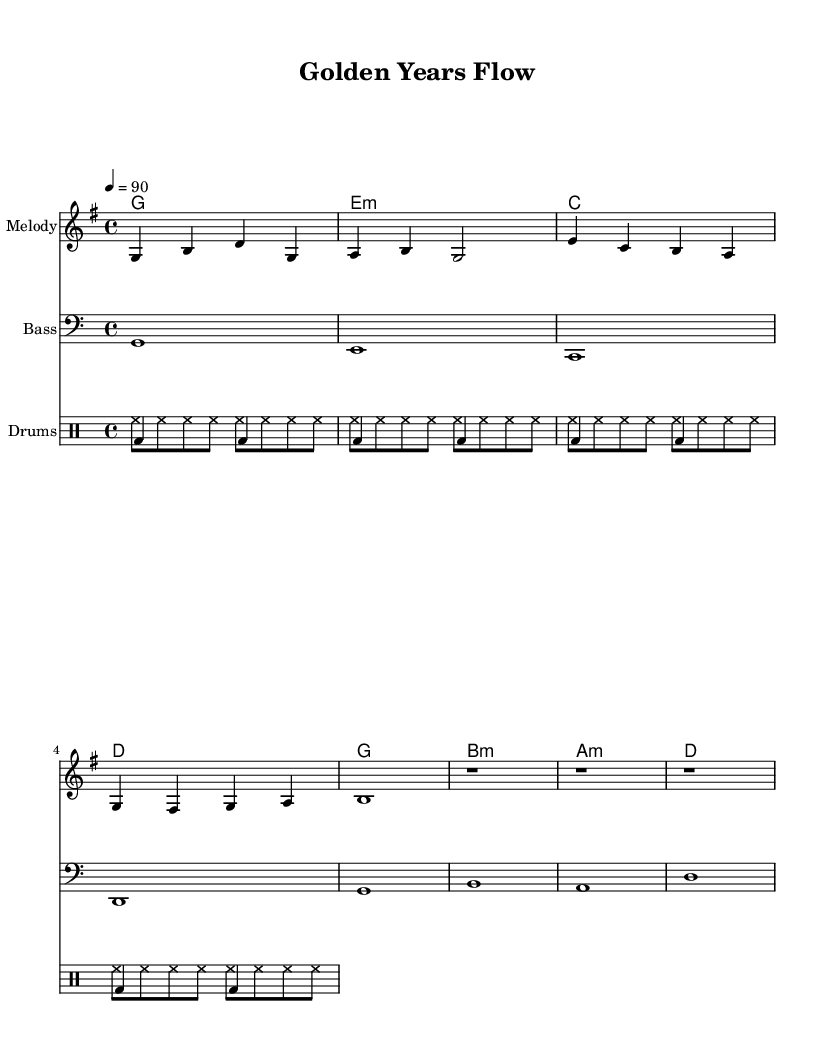What is the key signature of this music? The key signature reflects the presence of an F sharp and indicates it is in G major. This is determined by observing that there is one sharp in the key signature.
Answer: G major What is the time signature of this music? The time signature is found at the beginning of the score, shown as "4/4," indicating that there are four beats in each measure.
Answer: 4/4 What is the tempo marking of this piece? The tempo marking is indicated as "4 = 90" at the beginning of the score, signifying the beats per minute.
Answer: 90 How many measures are in the melody? Counting the distinct sets of notes separated by bar lines, there are 8 measures present in the melody section.
Answer: 8 Which instrument has the bass clef? The bass clef is identified in the score for the lower-pitched instrument lines, specifically noted in the staff header for the bass part.
Answer: Bass What message is conveyed in the lyrics? The lyrics emphasize themes of positivity and activity related to aging gracefully, summarizing the overall message of staying active and youthful.
Answer: Stay active and wise What rhythm style is used for the drums? The drum rhythm is characterized by a consistent pattern, which is typical in Hip Hop music, combining both kick and hi-hat sounds with a regular beat.
Answer: Hip Hop 